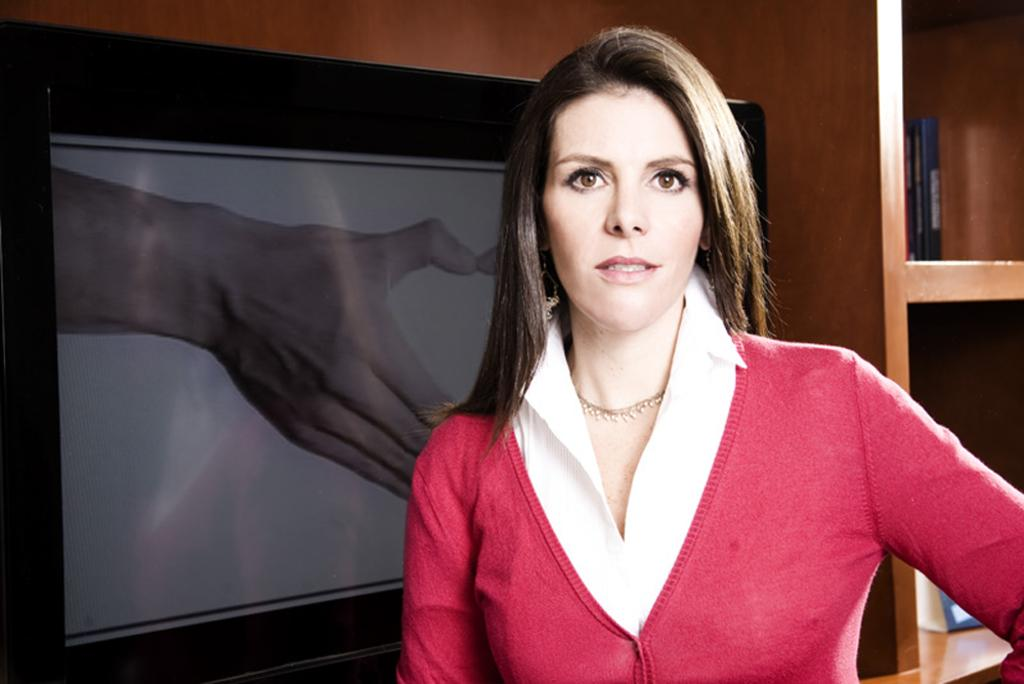What is the main subject of the image? There is a woman standing in the image. What is the woman wearing? The woman is wearing a red and white colored dress. What electronic device can be seen in the image? There is a television with a display in the image. What type of furniture is present in the image? There is a wooden rack in the image. What type of grass can be seen growing on the woman's dress in the image? There is no grass visible on the woman's dress in the image. How many people are present in the crowd in the image? There is no crowd present in the image; it features a woman standing, a television, and a wooden rack. 